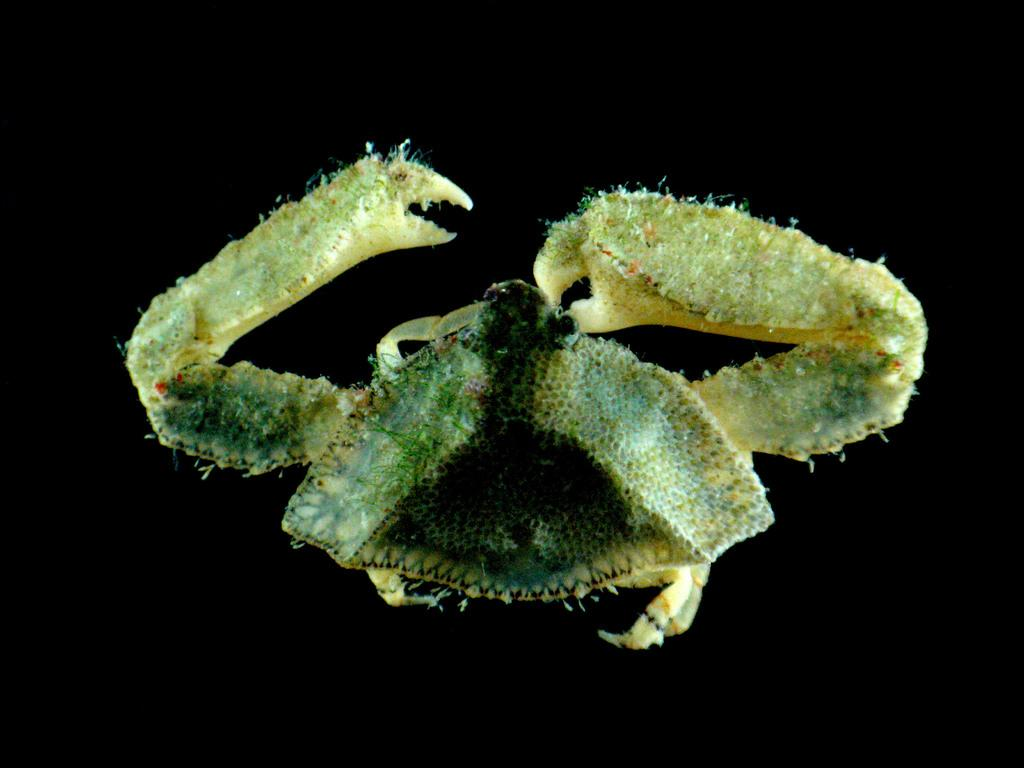What is the main subject of the image? There is a crab in the image. What color is the background of the image? The background of the image is black. What type of wrist accessory is being advertised in the image? There is no wrist accessory or advertisement present in the image; it features a crab against a black background. What kind of bread can be seen in the image? There is no bread present in the image; it features a crab against a black background. 